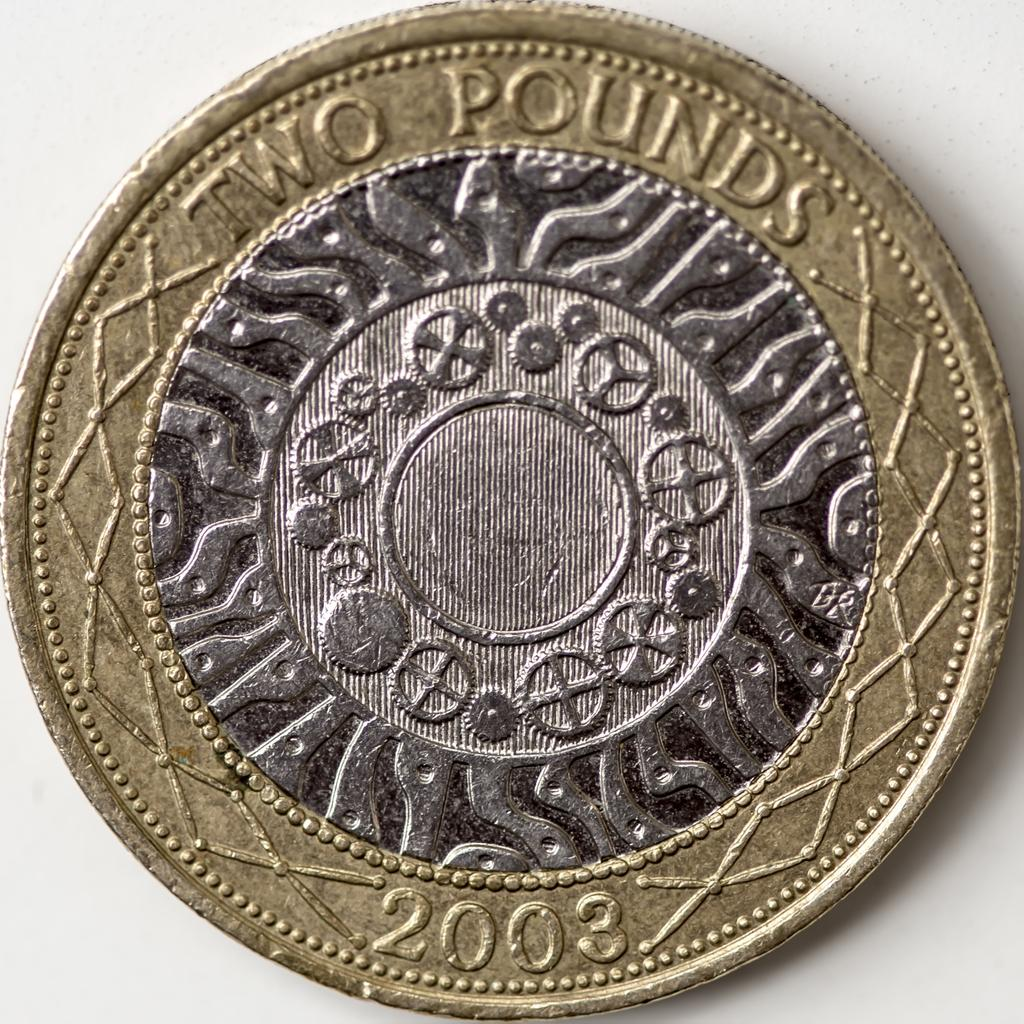<image>
Describe the image concisely. A coin from 2003 that has a value of two pounds. 